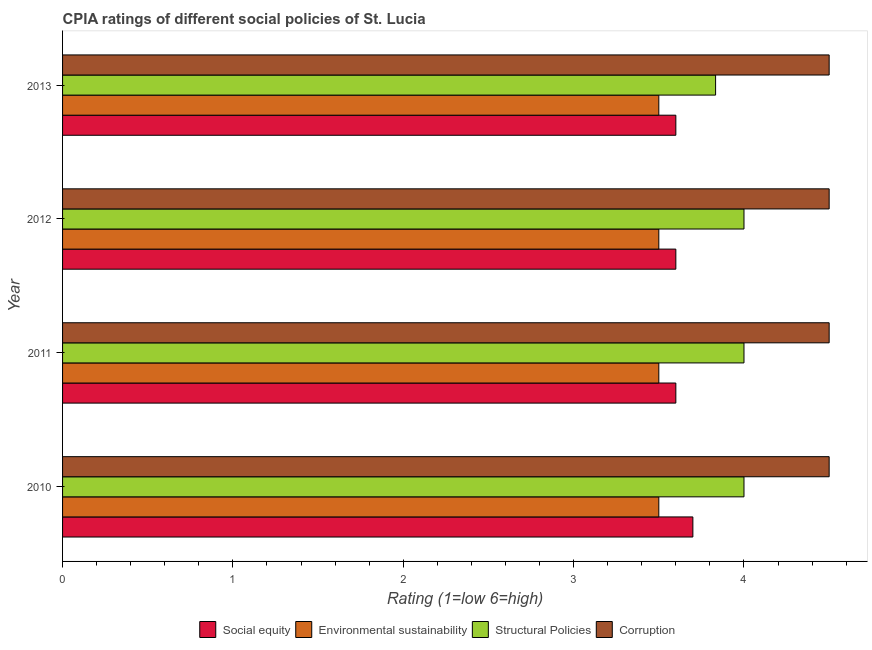Are the number of bars per tick equal to the number of legend labels?
Keep it short and to the point. Yes. Are the number of bars on each tick of the Y-axis equal?
Provide a short and direct response. Yes. What is the label of the 4th group of bars from the top?
Offer a very short reply. 2010. In how many cases, is the number of bars for a given year not equal to the number of legend labels?
Your response must be concise. 0. What is the cpia rating of environmental sustainability in 2013?
Your answer should be very brief. 3.5. Across all years, what is the maximum cpia rating of social equity?
Offer a very short reply. 3.7. Across all years, what is the minimum cpia rating of structural policies?
Offer a very short reply. 3.83. In which year was the cpia rating of environmental sustainability minimum?
Give a very brief answer. 2010. What is the total cpia rating of social equity in the graph?
Your answer should be very brief. 14.5. What is the difference between the cpia rating of corruption in 2013 and the cpia rating of social equity in 2012?
Make the answer very short. 0.9. What is the average cpia rating of environmental sustainability per year?
Your response must be concise. 3.5. In the year 2013, what is the difference between the cpia rating of corruption and cpia rating of structural policies?
Provide a succinct answer. 0.67. What is the ratio of the cpia rating of structural policies in 2011 to that in 2013?
Give a very brief answer. 1.04. Is the difference between the cpia rating of environmental sustainability in 2011 and 2013 greater than the difference between the cpia rating of social equity in 2011 and 2013?
Offer a very short reply. No. What is the difference between the highest and the second highest cpia rating of social equity?
Offer a very short reply. 0.1. In how many years, is the cpia rating of environmental sustainability greater than the average cpia rating of environmental sustainability taken over all years?
Your answer should be very brief. 0. Is the sum of the cpia rating of corruption in 2011 and 2013 greater than the maximum cpia rating of structural policies across all years?
Your response must be concise. Yes. Is it the case that in every year, the sum of the cpia rating of environmental sustainability and cpia rating of structural policies is greater than the sum of cpia rating of corruption and cpia rating of social equity?
Provide a succinct answer. Yes. What does the 4th bar from the top in 2010 represents?
Your response must be concise. Social equity. What does the 3rd bar from the bottom in 2013 represents?
Provide a short and direct response. Structural Policies. How many bars are there?
Offer a terse response. 16. Are all the bars in the graph horizontal?
Offer a very short reply. Yes. What is the difference between two consecutive major ticks on the X-axis?
Offer a terse response. 1. Are the values on the major ticks of X-axis written in scientific E-notation?
Provide a short and direct response. No. Does the graph contain any zero values?
Your answer should be very brief. No. Does the graph contain grids?
Provide a succinct answer. No. How many legend labels are there?
Give a very brief answer. 4. What is the title of the graph?
Provide a short and direct response. CPIA ratings of different social policies of St. Lucia. What is the label or title of the X-axis?
Keep it short and to the point. Rating (1=low 6=high). What is the label or title of the Y-axis?
Keep it short and to the point. Year. What is the Rating (1=low 6=high) of Environmental sustainability in 2010?
Offer a terse response. 3.5. What is the Rating (1=low 6=high) of Structural Policies in 2010?
Your answer should be very brief. 4. What is the Rating (1=low 6=high) of Corruption in 2010?
Ensure brevity in your answer.  4.5. What is the Rating (1=low 6=high) in Social equity in 2011?
Your response must be concise. 3.6. What is the Rating (1=low 6=high) in Environmental sustainability in 2011?
Offer a terse response. 3.5. What is the Rating (1=low 6=high) of Structural Policies in 2011?
Your answer should be compact. 4. What is the Rating (1=low 6=high) of Social equity in 2012?
Provide a succinct answer. 3.6. What is the Rating (1=low 6=high) of Environmental sustainability in 2012?
Give a very brief answer. 3.5. What is the Rating (1=low 6=high) of Structural Policies in 2012?
Keep it short and to the point. 4. What is the Rating (1=low 6=high) in Social equity in 2013?
Make the answer very short. 3.6. What is the Rating (1=low 6=high) in Structural Policies in 2013?
Provide a short and direct response. 3.83. Across all years, what is the maximum Rating (1=low 6=high) in Environmental sustainability?
Your answer should be compact. 3.5. Across all years, what is the maximum Rating (1=low 6=high) of Structural Policies?
Your response must be concise. 4. Across all years, what is the maximum Rating (1=low 6=high) of Corruption?
Your answer should be very brief. 4.5. Across all years, what is the minimum Rating (1=low 6=high) in Environmental sustainability?
Offer a terse response. 3.5. Across all years, what is the minimum Rating (1=low 6=high) in Structural Policies?
Ensure brevity in your answer.  3.83. Across all years, what is the minimum Rating (1=low 6=high) in Corruption?
Provide a succinct answer. 4.5. What is the total Rating (1=low 6=high) of Social equity in the graph?
Offer a terse response. 14.5. What is the total Rating (1=low 6=high) in Structural Policies in the graph?
Provide a succinct answer. 15.83. What is the total Rating (1=low 6=high) in Corruption in the graph?
Make the answer very short. 18. What is the difference between the Rating (1=low 6=high) of Social equity in 2010 and that in 2011?
Give a very brief answer. 0.1. What is the difference between the Rating (1=low 6=high) in Environmental sustainability in 2010 and that in 2011?
Your answer should be very brief. 0. What is the difference between the Rating (1=low 6=high) in Corruption in 2010 and that in 2011?
Offer a terse response. 0. What is the difference between the Rating (1=low 6=high) of Social equity in 2010 and that in 2012?
Your answer should be compact. 0.1. What is the difference between the Rating (1=low 6=high) of Environmental sustainability in 2010 and that in 2012?
Provide a succinct answer. 0. What is the difference between the Rating (1=low 6=high) of Environmental sustainability in 2011 and that in 2012?
Your answer should be compact. 0. What is the difference between the Rating (1=low 6=high) of Social equity in 2011 and that in 2013?
Your answer should be compact. 0. What is the difference between the Rating (1=low 6=high) in Environmental sustainability in 2011 and that in 2013?
Give a very brief answer. 0. What is the difference between the Rating (1=low 6=high) of Structural Policies in 2011 and that in 2013?
Provide a short and direct response. 0.17. What is the difference between the Rating (1=low 6=high) of Environmental sustainability in 2012 and that in 2013?
Ensure brevity in your answer.  0. What is the difference between the Rating (1=low 6=high) in Corruption in 2012 and that in 2013?
Offer a very short reply. 0. What is the difference between the Rating (1=low 6=high) of Social equity in 2010 and the Rating (1=low 6=high) of Environmental sustainability in 2011?
Your answer should be compact. 0.2. What is the difference between the Rating (1=low 6=high) in Social equity in 2010 and the Rating (1=low 6=high) in Structural Policies in 2011?
Make the answer very short. -0.3. What is the difference between the Rating (1=low 6=high) in Structural Policies in 2010 and the Rating (1=low 6=high) in Corruption in 2011?
Your response must be concise. -0.5. What is the difference between the Rating (1=low 6=high) of Social equity in 2010 and the Rating (1=low 6=high) of Structural Policies in 2012?
Provide a succinct answer. -0.3. What is the difference between the Rating (1=low 6=high) of Social equity in 2010 and the Rating (1=low 6=high) of Structural Policies in 2013?
Keep it short and to the point. -0.13. What is the difference between the Rating (1=low 6=high) of Structural Policies in 2010 and the Rating (1=low 6=high) of Corruption in 2013?
Keep it short and to the point. -0.5. What is the difference between the Rating (1=low 6=high) in Social equity in 2011 and the Rating (1=low 6=high) in Structural Policies in 2012?
Your answer should be very brief. -0.4. What is the difference between the Rating (1=low 6=high) in Social equity in 2011 and the Rating (1=low 6=high) in Structural Policies in 2013?
Your answer should be compact. -0.23. What is the difference between the Rating (1=low 6=high) in Social equity in 2011 and the Rating (1=low 6=high) in Corruption in 2013?
Make the answer very short. -0.9. What is the difference between the Rating (1=low 6=high) of Environmental sustainability in 2011 and the Rating (1=low 6=high) of Corruption in 2013?
Give a very brief answer. -1. What is the difference between the Rating (1=low 6=high) in Structural Policies in 2011 and the Rating (1=low 6=high) in Corruption in 2013?
Keep it short and to the point. -0.5. What is the difference between the Rating (1=low 6=high) in Social equity in 2012 and the Rating (1=low 6=high) in Environmental sustainability in 2013?
Your answer should be very brief. 0.1. What is the difference between the Rating (1=low 6=high) of Social equity in 2012 and the Rating (1=low 6=high) of Structural Policies in 2013?
Offer a terse response. -0.23. What is the difference between the Rating (1=low 6=high) in Social equity in 2012 and the Rating (1=low 6=high) in Corruption in 2013?
Provide a short and direct response. -0.9. What is the difference between the Rating (1=low 6=high) in Environmental sustainability in 2012 and the Rating (1=low 6=high) in Corruption in 2013?
Provide a short and direct response. -1. What is the average Rating (1=low 6=high) of Social equity per year?
Ensure brevity in your answer.  3.62. What is the average Rating (1=low 6=high) in Structural Policies per year?
Your answer should be compact. 3.96. In the year 2010, what is the difference between the Rating (1=low 6=high) of Social equity and Rating (1=low 6=high) of Environmental sustainability?
Your answer should be compact. 0.2. In the year 2010, what is the difference between the Rating (1=low 6=high) of Social equity and Rating (1=low 6=high) of Structural Policies?
Provide a succinct answer. -0.3. In the year 2010, what is the difference between the Rating (1=low 6=high) of Social equity and Rating (1=low 6=high) of Corruption?
Keep it short and to the point. -0.8. In the year 2010, what is the difference between the Rating (1=low 6=high) in Environmental sustainability and Rating (1=low 6=high) in Structural Policies?
Provide a succinct answer. -0.5. In the year 2010, what is the difference between the Rating (1=low 6=high) of Structural Policies and Rating (1=low 6=high) of Corruption?
Your answer should be compact. -0.5. In the year 2011, what is the difference between the Rating (1=low 6=high) of Social equity and Rating (1=low 6=high) of Environmental sustainability?
Give a very brief answer. 0.1. In the year 2011, what is the difference between the Rating (1=low 6=high) of Social equity and Rating (1=low 6=high) of Structural Policies?
Offer a very short reply. -0.4. In the year 2011, what is the difference between the Rating (1=low 6=high) of Social equity and Rating (1=low 6=high) of Corruption?
Your response must be concise. -0.9. In the year 2011, what is the difference between the Rating (1=low 6=high) of Environmental sustainability and Rating (1=low 6=high) of Structural Policies?
Offer a very short reply. -0.5. In the year 2012, what is the difference between the Rating (1=low 6=high) of Social equity and Rating (1=low 6=high) of Corruption?
Provide a succinct answer. -0.9. In the year 2012, what is the difference between the Rating (1=low 6=high) of Environmental sustainability and Rating (1=low 6=high) of Structural Policies?
Your response must be concise. -0.5. In the year 2012, what is the difference between the Rating (1=low 6=high) in Environmental sustainability and Rating (1=low 6=high) in Corruption?
Offer a terse response. -1. In the year 2013, what is the difference between the Rating (1=low 6=high) of Social equity and Rating (1=low 6=high) of Structural Policies?
Offer a very short reply. -0.23. In the year 2013, what is the difference between the Rating (1=low 6=high) in Social equity and Rating (1=low 6=high) in Corruption?
Provide a short and direct response. -0.9. What is the ratio of the Rating (1=low 6=high) in Social equity in 2010 to that in 2011?
Your answer should be very brief. 1.03. What is the ratio of the Rating (1=low 6=high) in Structural Policies in 2010 to that in 2011?
Keep it short and to the point. 1. What is the ratio of the Rating (1=low 6=high) in Corruption in 2010 to that in 2011?
Your response must be concise. 1. What is the ratio of the Rating (1=low 6=high) of Social equity in 2010 to that in 2012?
Provide a succinct answer. 1.03. What is the ratio of the Rating (1=low 6=high) of Structural Policies in 2010 to that in 2012?
Provide a succinct answer. 1. What is the ratio of the Rating (1=low 6=high) of Corruption in 2010 to that in 2012?
Provide a succinct answer. 1. What is the ratio of the Rating (1=low 6=high) in Social equity in 2010 to that in 2013?
Give a very brief answer. 1.03. What is the ratio of the Rating (1=low 6=high) of Structural Policies in 2010 to that in 2013?
Make the answer very short. 1.04. What is the ratio of the Rating (1=low 6=high) in Corruption in 2010 to that in 2013?
Make the answer very short. 1. What is the ratio of the Rating (1=low 6=high) of Social equity in 2011 to that in 2012?
Give a very brief answer. 1. What is the ratio of the Rating (1=low 6=high) of Environmental sustainability in 2011 to that in 2012?
Provide a short and direct response. 1. What is the ratio of the Rating (1=low 6=high) of Structural Policies in 2011 to that in 2013?
Offer a terse response. 1.04. What is the ratio of the Rating (1=low 6=high) of Corruption in 2011 to that in 2013?
Provide a short and direct response. 1. What is the ratio of the Rating (1=low 6=high) in Social equity in 2012 to that in 2013?
Provide a short and direct response. 1. What is the ratio of the Rating (1=low 6=high) of Structural Policies in 2012 to that in 2013?
Make the answer very short. 1.04. What is the ratio of the Rating (1=low 6=high) in Corruption in 2012 to that in 2013?
Provide a short and direct response. 1. What is the difference between the highest and the second highest Rating (1=low 6=high) in Social equity?
Your answer should be compact. 0.1. What is the difference between the highest and the second highest Rating (1=low 6=high) of Environmental sustainability?
Give a very brief answer. 0. What is the difference between the highest and the second highest Rating (1=low 6=high) in Structural Policies?
Your answer should be compact. 0. What is the difference between the highest and the lowest Rating (1=low 6=high) of Social equity?
Offer a terse response. 0.1. What is the difference between the highest and the lowest Rating (1=low 6=high) in Corruption?
Ensure brevity in your answer.  0. 